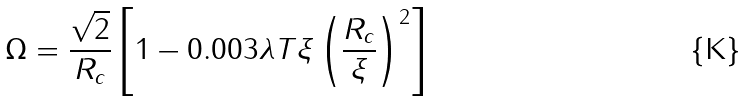Convert formula to latex. <formula><loc_0><loc_0><loc_500><loc_500>\Omega = \frac { \sqrt { 2 } } { R _ { c } } \left [ 1 - 0 . 0 0 3 \lambda T \xi \left ( \frac { R _ { c } } { \xi } \right ) ^ { 2 } \right ]</formula> 